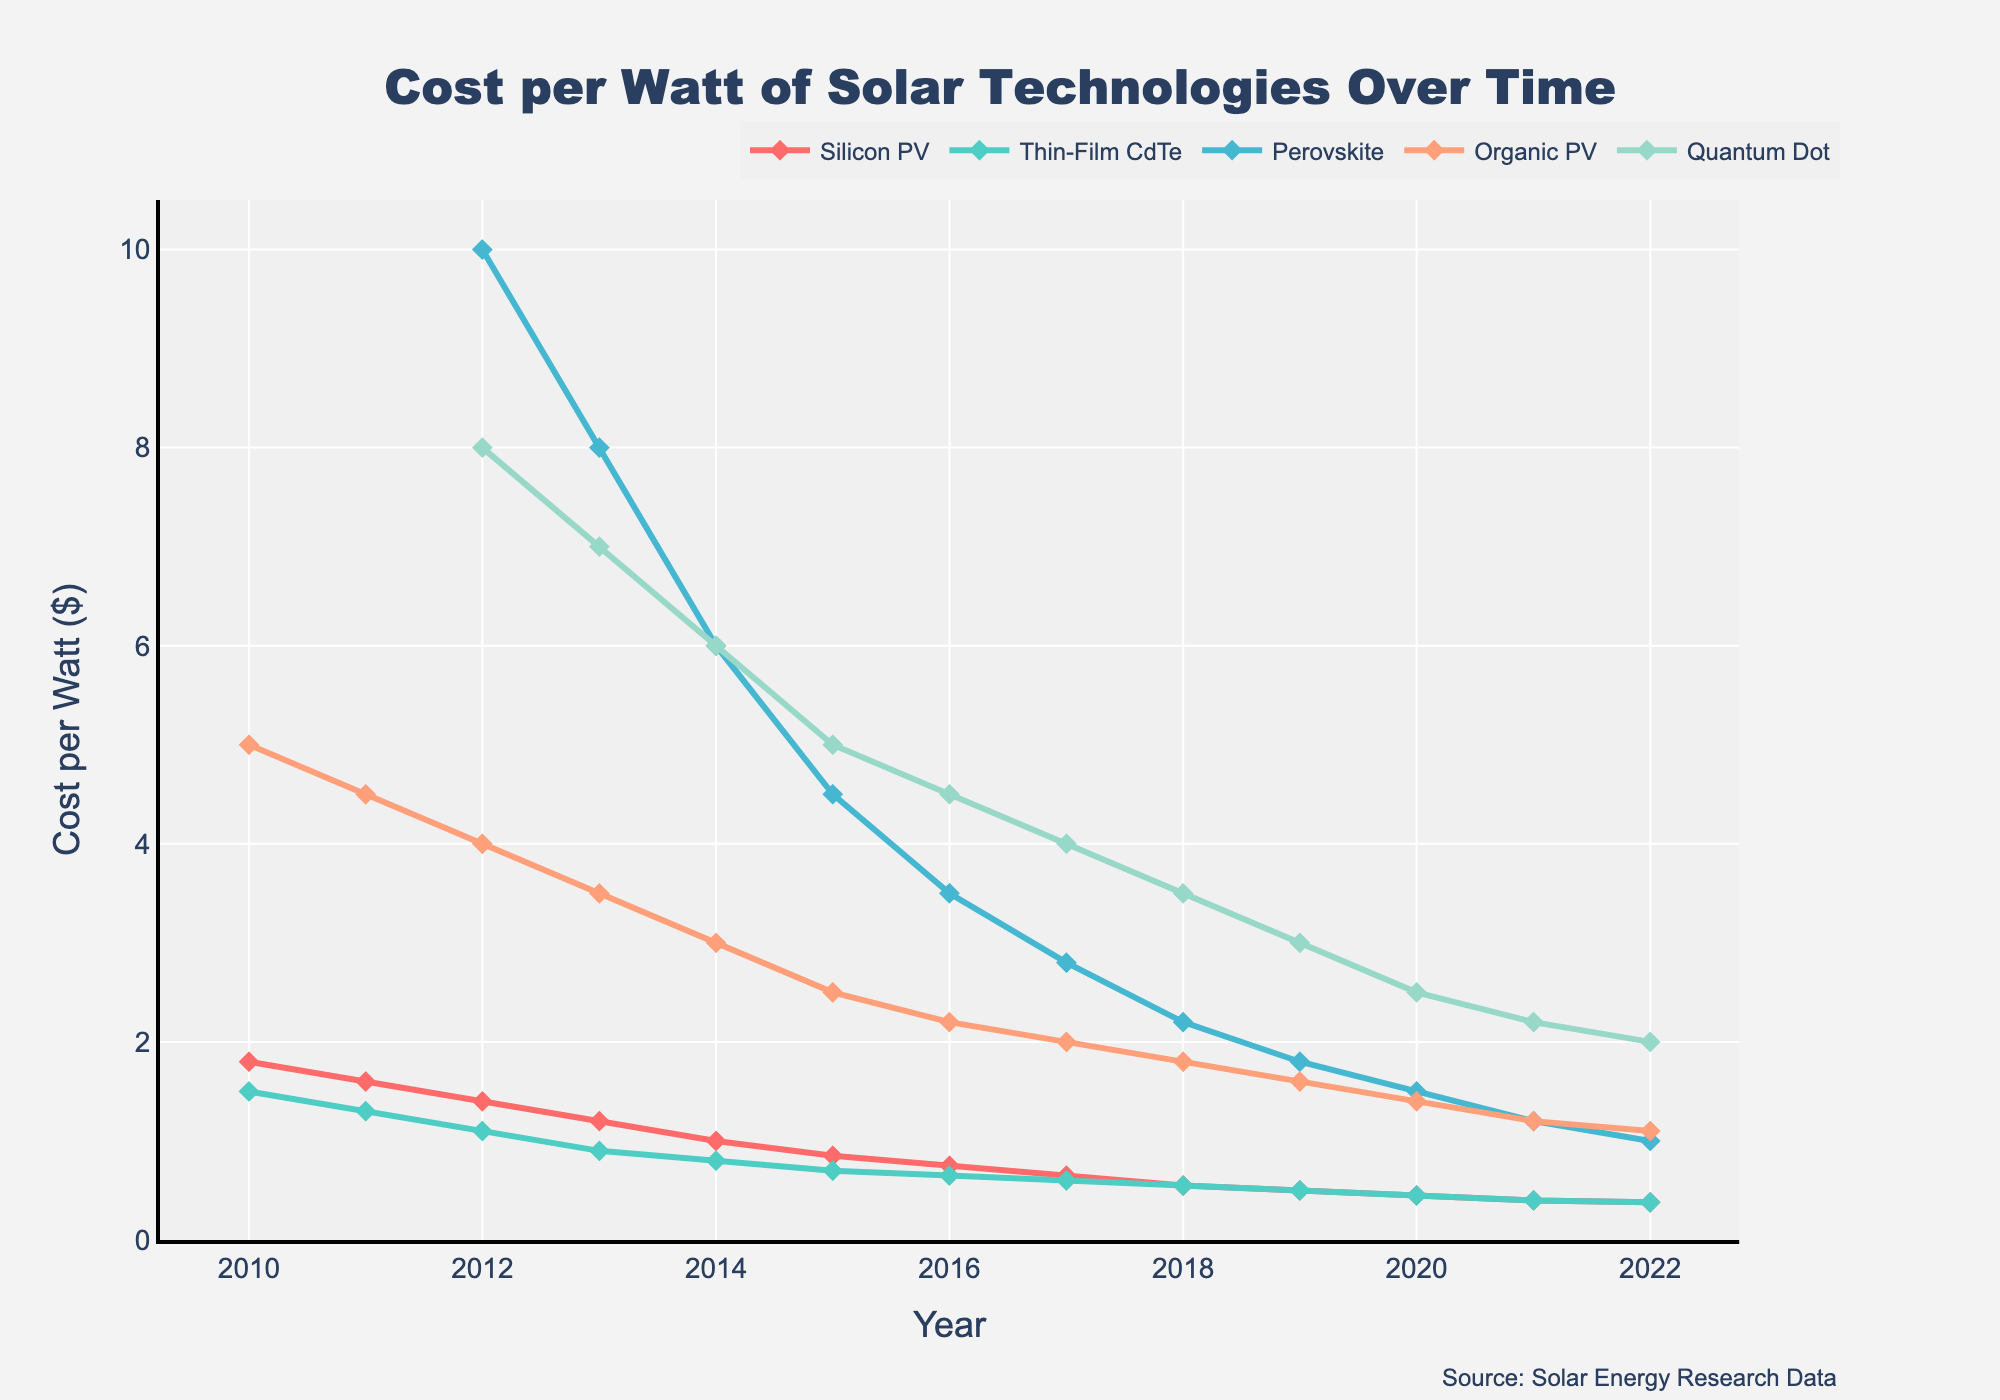what is the average cost per watt of Silicon PV from 2010 to 2022? To find the average, sum up the yearly costs of Silicon PV from 2010 to 2022 and then divide by the number of years (13 years). Sum = 1.80 + 1.60 + 1.40 + 1.20 + 1.00 + 0.85 + 0.75 + 0.65 + 0.55 + 0.50 + 0.45 + 0.40 + 0.38 = 11.53, Average = 11.53 / 13.
Answer: 0.89 Which solar technology had the highest cost per watt in 2012? By looking at the 2012 data, we find: Silicon PV (1.40), Thin-Film CdTe (1.10), Perovskite (10.00), Organic PV (4.00), Quantum Dot (8.00). Perovskite has the highest cost at 10.00 per watt.
Answer: Perovskite How has the cost of Quantum Dot technology changed from 2012 to 2022? Subtract the 2022 cost from the 2012 cost. The costs in 2012 and 2022 are 8.00 and 2.00, respectively. Change = 8.00 - 2.00 = 6.00. Hence, the cost has decreased by $6 per watt.
Answer: Decreased by $6 Compare the cost trends of Thin-Film CdTe and Organic PV technologies from 2010 to 2022. Observing the plotted lines reveals that Thin-Film CdTe starts at 1.50 in 2010 and decreases steadily to 0.38 in 2022. Organic PV technology starts higher at 5.00 in 2010 but also declines steadily to 1.10 in 2022, showing a more significant decline.
Answer: Both decreased, Organic PV more significantly Which year did Silicon PV drop below the cost of $1 per watt? Looking at the plotted line for Silicon PV, it drops below $1 per watt in 2014 when the cost was exactly 1.00.
Answer: 2014 What is the trend for Perovskite technology from 2012 to 2022? From the chart, Perovskite starts at 10.00 in 2012 and falls yearly to reach 1.00 in 2022. The trend is a consistent decline in cost per watt.
Answer: Decreasing Between 2018 and 2022, which technology showed the least reduction in cost per watt? By comparing the costs of all technologies between 2018 and 2022, we see Silicon PV went from 0.55 to 0.38, Thin-Film CdTe from 0.55 to 0.38, Perovskite from 2.20 to 1.00, Organic PV from 1.80 to 1.10, and Quantum Dot from 3.50 to 2.00. Both Silicon PV and Thin-Film CdTe reduced by 0.17, which is the least among all.
Answer: Silicon PV and Thin-Film CdTe What was the cost difference between Organic PV and Quantum Dot technologies in 2020? To find the difference, subtract the cost of Organic PV from Quantum Dot in 2020. Organic PV cost = 1.40, Quantum Dot cost = 2.50. Difference = 2.50 - 1.40 = 1.10.
Answer: 1.10 Which technology had the steepest decline in cost from 2016 to 2017? To determine the steepest decline, we compare the cost changes between 2016 and 2017 for all technologies: Silicon PV (0.75 to 0.65 = 0.10), Thin-Film CdTe (0.65 to 0.60 = 0.05), Perovskite (3.50 to 2.80 = 0.70), Organic PV (2.20 to 2.00 = 0.20), Quantum Dot (4.50 to 4.00 = 0.50). Perovskite shows the steepest decline of 0.70.
Answer: Perovskite 